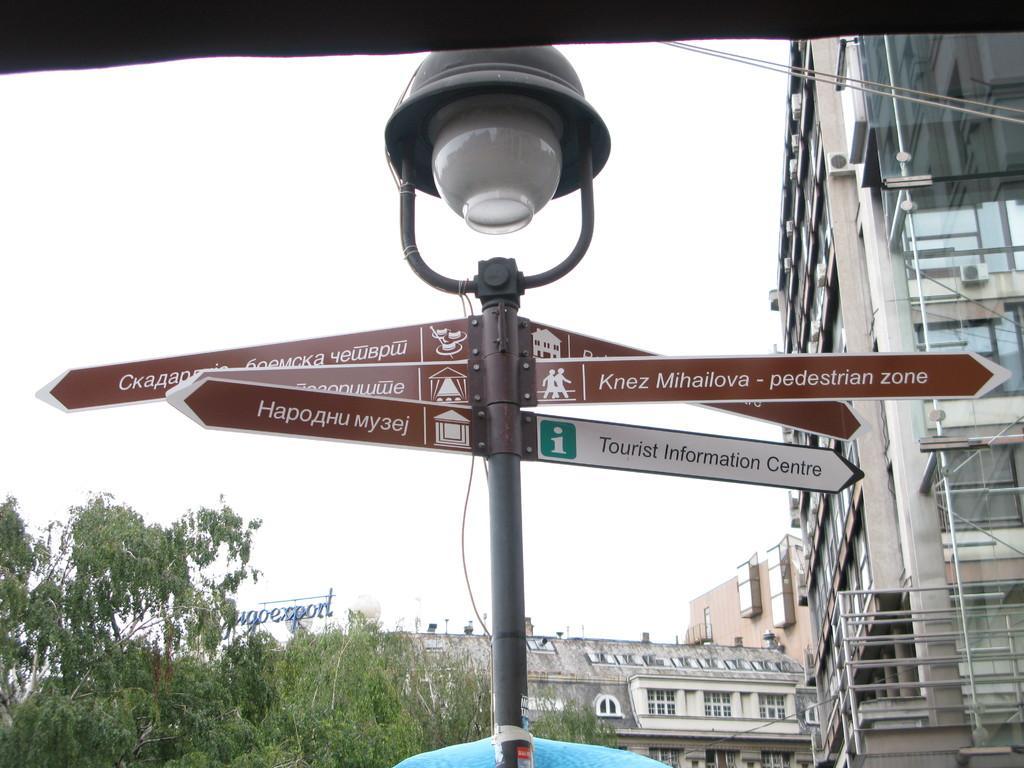Can you describe this image briefly? In this picture there is a lamp post with street direction names. Behind there is a glass building and on the left side there are some trees. 